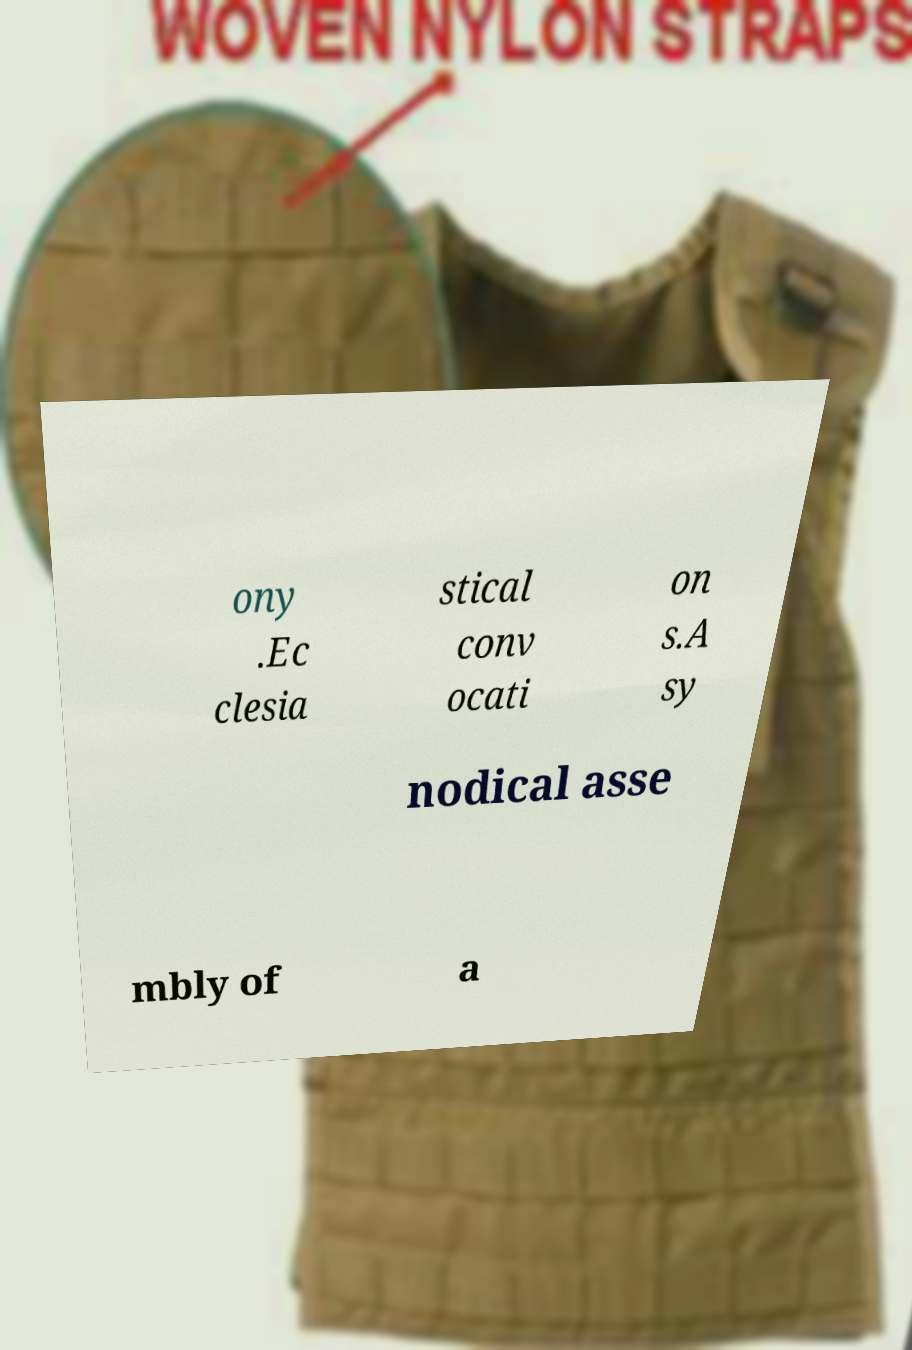Can you accurately transcribe the text from the provided image for me? ony .Ec clesia stical conv ocati on s.A sy nodical asse mbly of a 